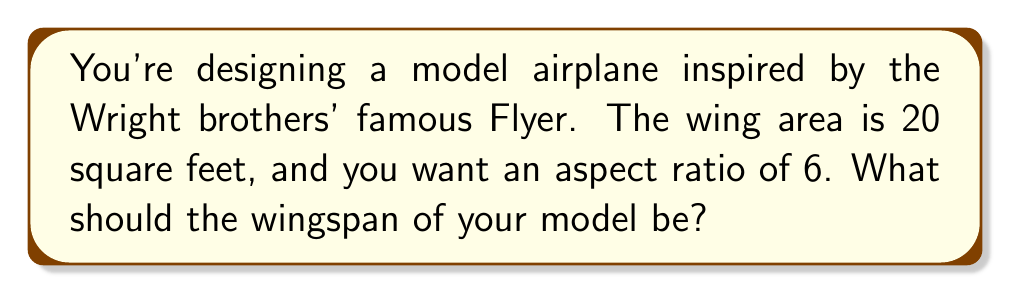Give your solution to this math problem. Let's approach this step-by-step:

1) First, recall the formula for aspect ratio (AR):
   $$ AR = \frac{\text{wingspan}^2}{\text{wing area}} $$

2) We're given:
   - Aspect ratio (AR) = 6
   - Wing area = 20 sq ft

3) Let's denote wingspan as $w$. Substituting into the formula:
   $$ 6 = \frac{w^2}{20} $$

4) Multiply both sides by 20:
   $$ 120 = w^2 $$

5) Take the square root of both sides:
   $$ \sqrt{120} = w $$

6) Simplify:
   $$ w = \sqrt{120} = \sqrt{4 \times 30} = 2\sqrt{30} \approx 10.95 \text{ ft} $$

Thus, the wingspan should be approximately 10.95 feet.
Answer: $2\sqrt{30}$ ft $\approx 10.95$ ft 